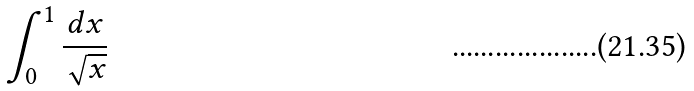<formula> <loc_0><loc_0><loc_500><loc_500>\int _ { 0 } ^ { 1 } \frac { d x } { \sqrt { x } }</formula> 